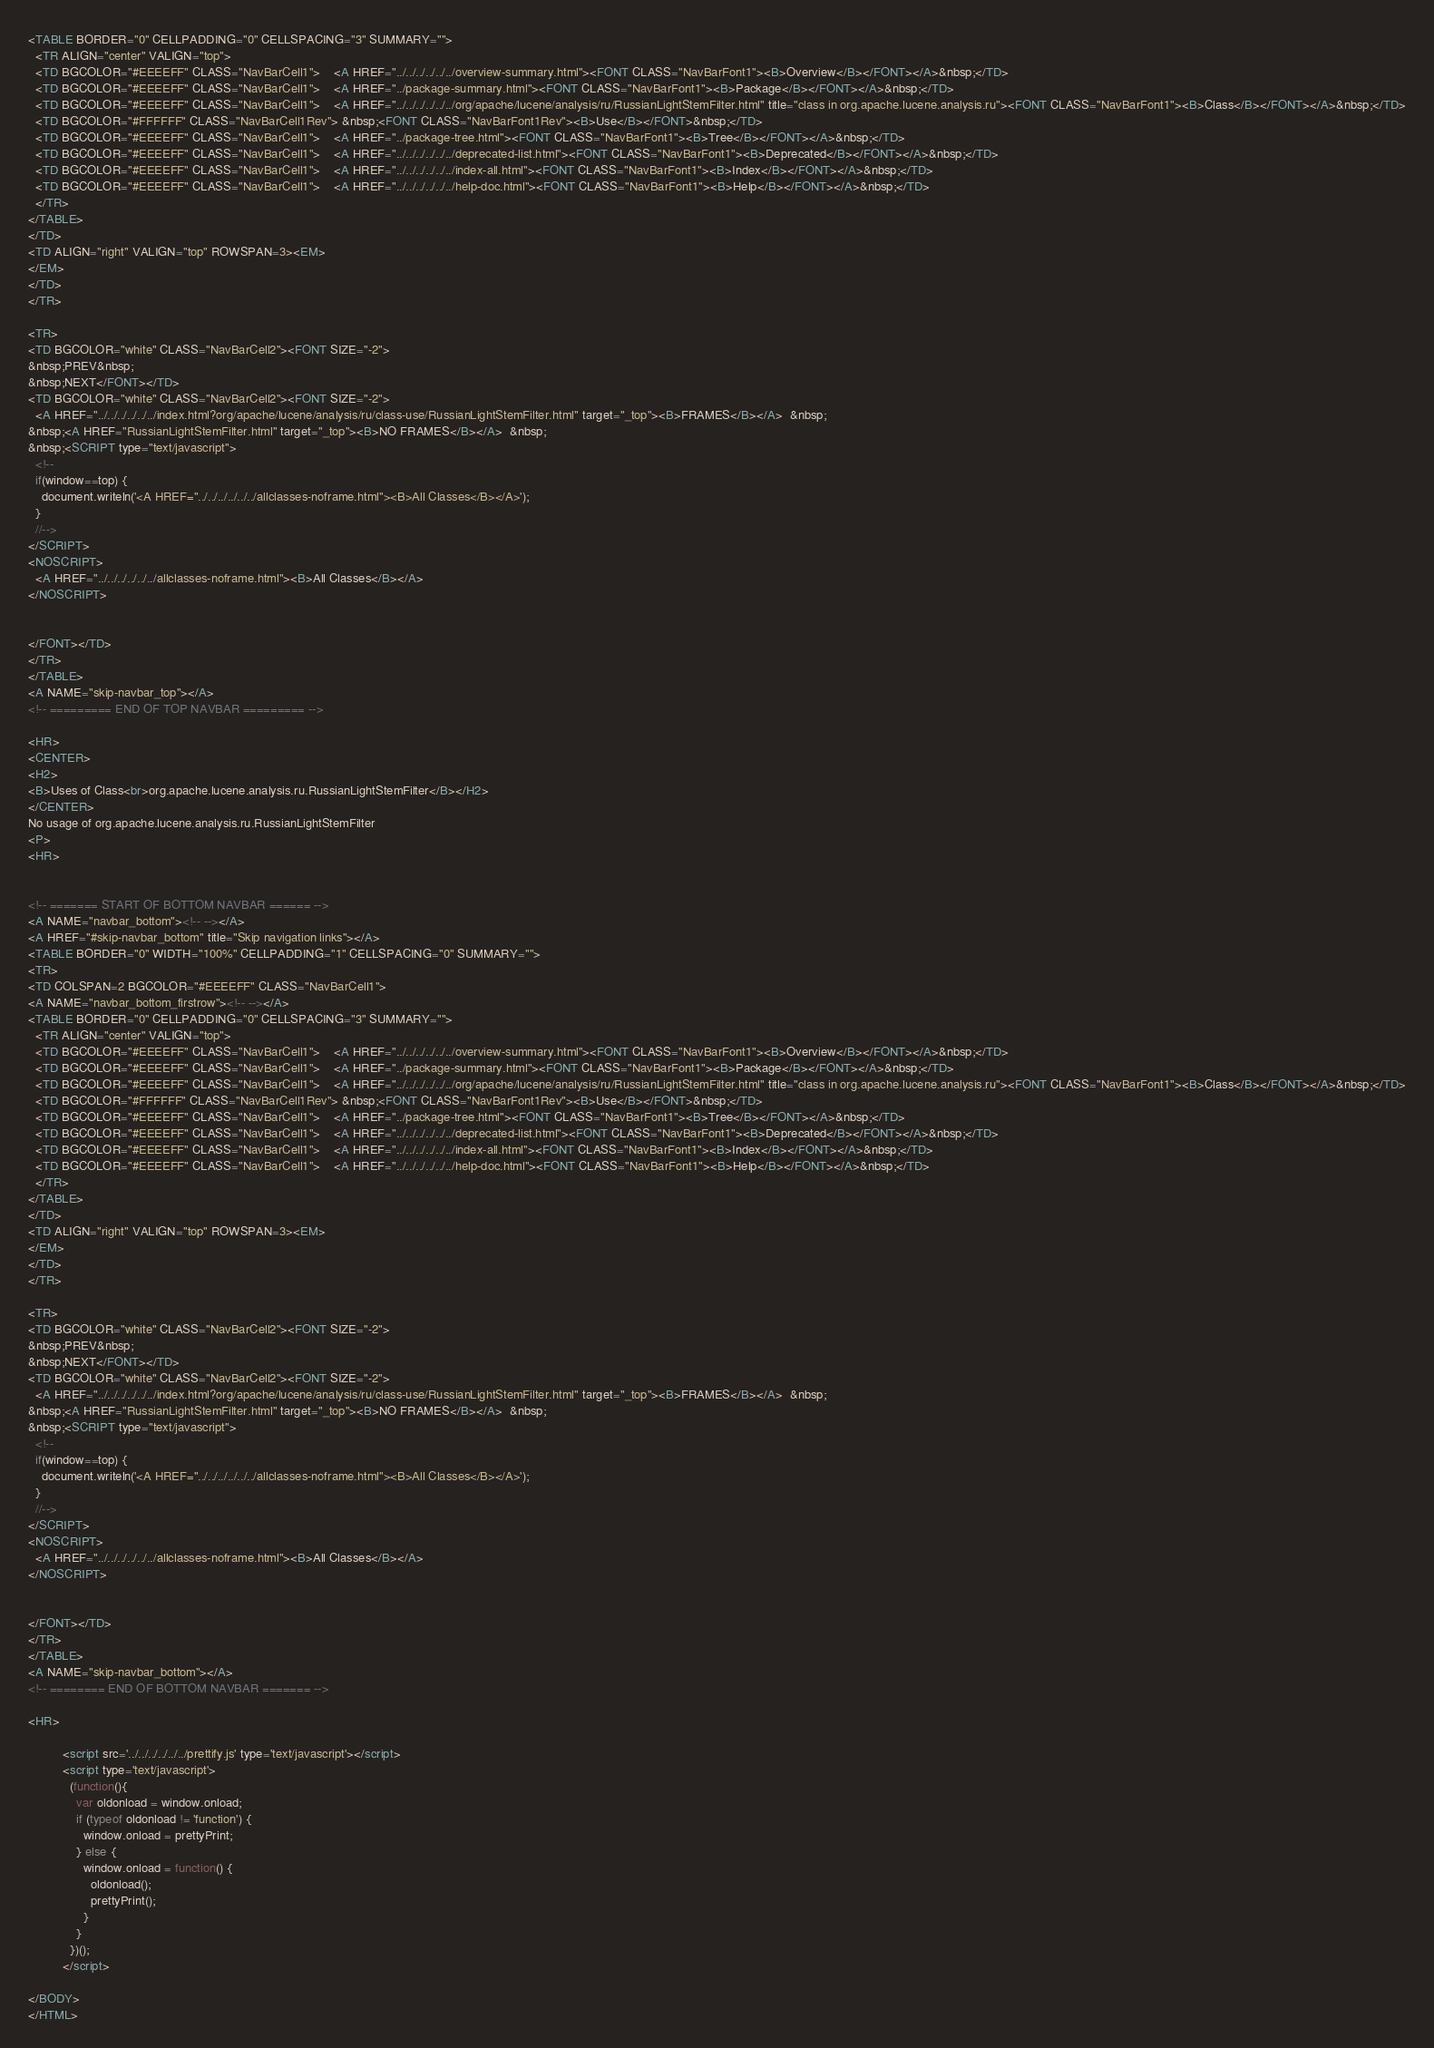Convert code to text. <code><loc_0><loc_0><loc_500><loc_500><_HTML_><TABLE BORDER="0" CELLPADDING="0" CELLSPACING="3" SUMMARY="">
  <TR ALIGN="center" VALIGN="top">
  <TD BGCOLOR="#EEEEFF" CLASS="NavBarCell1">    <A HREF="../../../../../../overview-summary.html"><FONT CLASS="NavBarFont1"><B>Overview</B></FONT></A>&nbsp;</TD>
  <TD BGCOLOR="#EEEEFF" CLASS="NavBarCell1">    <A HREF="../package-summary.html"><FONT CLASS="NavBarFont1"><B>Package</B></FONT></A>&nbsp;</TD>
  <TD BGCOLOR="#EEEEFF" CLASS="NavBarCell1">    <A HREF="../../../../../../org/apache/lucene/analysis/ru/RussianLightStemFilter.html" title="class in org.apache.lucene.analysis.ru"><FONT CLASS="NavBarFont1"><B>Class</B></FONT></A>&nbsp;</TD>
  <TD BGCOLOR="#FFFFFF" CLASS="NavBarCell1Rev"> &nbsp;<FONT CLASS="NavBarFont1Rev"><B>Use</B></FONT>&nbsp;</TD>
  <TD BGCOLOR="#EEEEFF" CLASS="NavBarCell1">    <A HREF="../package-tree.html"><FONT CLASS="NavBarFont1"><B>Tree</B></FONT></A>&nbsp;</TD>
  <TD BGCOLOR="#EEEEFF" CLASS="NavBarCell1">    <A HREF="../../../../../../deprecated-list.html"><FONT CLASS="NavBarFont1"><B>Deprecated</B></FONT></A>&nbsp;</TD>
  <TD BGCOLOR="#EEEEFF" CLASS="NavBarCell1">    <A HREF="../../../../../../index-all.html"><FONT CLASS="NavBarFont1"><B>Index</B></FONT></A>&nbsp;</TD>
  <TD BGCOLOR="#EEEEFF" CLASS="NavBarCell1">    <A HREF="../../../../../../help-doc.html"><FONT CLASS="NavBarFont1"><B>Help</B></FONT></A>&nbsp;</TD>
  </TR>
</TABLE>
</TD>
<TD ALIGN="right" VALIGN="top" ROWSPAN=3><EM>
</EM>
</TD>
</TR>

<TR>
<TD BGCOLOR="white" CLASS="NavBarCell2"><FONT SIZE="-2">
&nbsp;PREV&nbsp;
&nbsp;NEXT</FONT></TD>
<TD BGCOLOR="white" CLASS="NavBarCell2"><FONT SIZE="-2">
  <A HREF="../../../../../../index.html?org/apache/lucene/analysis/ru/class-use/RussianLightStemFilter.html" target="_top"><B>FRAMES</B></A>  &nbsp;
&nbsp;<A HREF="RussianLightStemFilter.html" target="_top"><B>NO FRAMES</B></A>  &nbsp;
&nbsp;<SCRIPT type="text/javascript">
  <!--
  if(window==top) {
    document.writeln('<A HREF="../../../../../../allclasses-noframe.html"><B>All Classes</B></A>');
  }
  //-->
</SCRIPT>
<NOSCRIPT>
  <A HREF="../../../../../../allclasses-noframe.html"><B>All Classes</B></A>
</NOSCRIPT>


</FONT></TD>
</TR>
</TABLE>
<A NAME="skip-navbar_top"></A>
<!-- ========= END OF TOP NAVBAR ========= -->

<HR>
<CENTER>
<H2>
<B>Uses of Class<br>org.apache.lucene.analysis.ru.RussianLightStemFilter</B></H2>
</CENTER>
No usage of org.apache.lucene.analysis.ru.RussianLightStemFilter
<P>
<HR>


<!-- ======= START OF BOTTOM NAVBAR ====== -->
<A NAME="navbar_bottom"><!-- --></A>
<A HREF="#skip-navbar_bottom" title="Skip navigation links"></A>
<TABLE BORDER="0" WIDTH="100%" CELLPADDING="1" CELLSPACING="0" SUMMARY="">
<TR>
<TD COLSPAN=2 BGCOLOR="#EEEEFF" CLASS="NavBarCell1">
<A NAME="navbar_bottom_firstrow"><!-- --></A>
<TABLE BORDER="0" CELLPADDING="0" CELLSPACING="3" SUMMARY="">
  <TR ALIGN="center" VALIGN="top">
  <TD BGCOLOR="#EEEEFF" CLASS="NavBarCell1">    <A HREF="../../../../../../overview-summary.html"><FONT CLASS="NavBarFont1"><B>Overview</B></FONT></A>&nbsp;</TD>
  <TD BGCOLOR="#EEEEFF" CLASS="NavBarCell1">    <A HREF="../package-summary.html"><FONT CLASS="NavBarFont1"><B>Package</B></FONT></A>&nbsp;</TD>
  <TD BGCOLOR="#EEEEFF" CLASS="NavBarCell1">    <A HREF="../../../../../../org/apache/lucene/analysis/ru/RussianLightStemFilter.html" title="class in org.apache.lucene.analysis.ru"><FONT CLASS="NavBarFont1"><B>Class</B></FONT></A>&nbsp;</TD>
  <TD BGCOLOR="#FFFFFF" CLASS="NavBarCell1Rev"> &nbsp;<FONT CLASS="NavBarFont1Rev"><B>Use</B></FONT>&nbsp;</TD>
  <TD BGCOLOR="#EEEEFF" CLASS="NavBarCell1">    <A HREF="../package-tree.html"><FONT CLASS="NavBarFont1"><B>Tree</B></FONT></A>&nbsp;</TD>
  <TD BGCOLOR="#EEEEFF" CLASS="NavBarCell1">    <A HREF="../../../../../../deprecated-list.html"><FONT CLASS="NavBarFont1"><B>Deprecated</B></FONT></A>&nbsp;</TD>
  <TD BGCOLOR="#EEEEFF" CLASS="NavBarCell1">    <A HREF="../../../../../../index-all.html"><FONT CLASS="NavBarFont1"><B>Index</B></FONT></A>&nbsp;</TD>
  <TD BGCOLOR="#EEEEFF" CLASS="NavBarCell1">    <A HREF="../../../../../../help-doc.html"><FONT CLASS="NavBarFont1"><B>Help</B></FONT></A>&nbsp;</TD>
  </TR>
</TABLE>
</TD>
<TD ALIGN="right" VALIGN="top" ROWSPAN=3><EM>
</EM>
</TD>
</TR>

<TR>
<TD BGCOLOR="white" CLASS="NavBarCell2"><FONT SIZE="-2">
&nbsp;PREV&nbsp;
&nbsp;NEXT</FONT></TD>
<TD BGCOLOR="white" CLASS="NavBarCell2"><FONT SIZE="-2">
  <A HREF="../../../../../../index.html?org/apache/lucene/analysis/ru/class-use/RussianLightStemFilter.html" target="_top"><B>FRAMES</B></A>  &nbsp;
&nbsp;<A HREF="RussianLightStemFilter.html" target="_top"><B>NO FRAMES</B></A>  &nbsp;
&nbsp;<SCRIPT type="text/javascript">
  <!--
  if(window==top) {
    document.writeln('<A HREF="../../../../../../allclasses-noframe.html"><B>All Classes</B></A>');
  }
  //-->
</SCRIPT>
<NOSCRIPT>
  <A HREF="../../../../../../allclasses-noframe.html"><B>All Classes</B></A>
</NOSCRIPT>


</FONT></TD>
</TR>
</TABLE>
<A NAME="skip-navbar_bottom"></A>
<!-- ======== END OF BOTTOM NAVBAR ======= -->

<HR>

          <script src='../../../../../../prettify.js' type='text/javascript'></script>
          <script type='text/javascript'>
            (function(){
              var oldonload = window.onload;
              if (typeof oldonload != 'function') {
                window.onload = prettyPrint;
              } else {
                window.onload = function() {
                  oldonload();
                  prettyPrint();
                }
              }
            })();
          </script>
        
</BODY>
</HTML>
</code> 